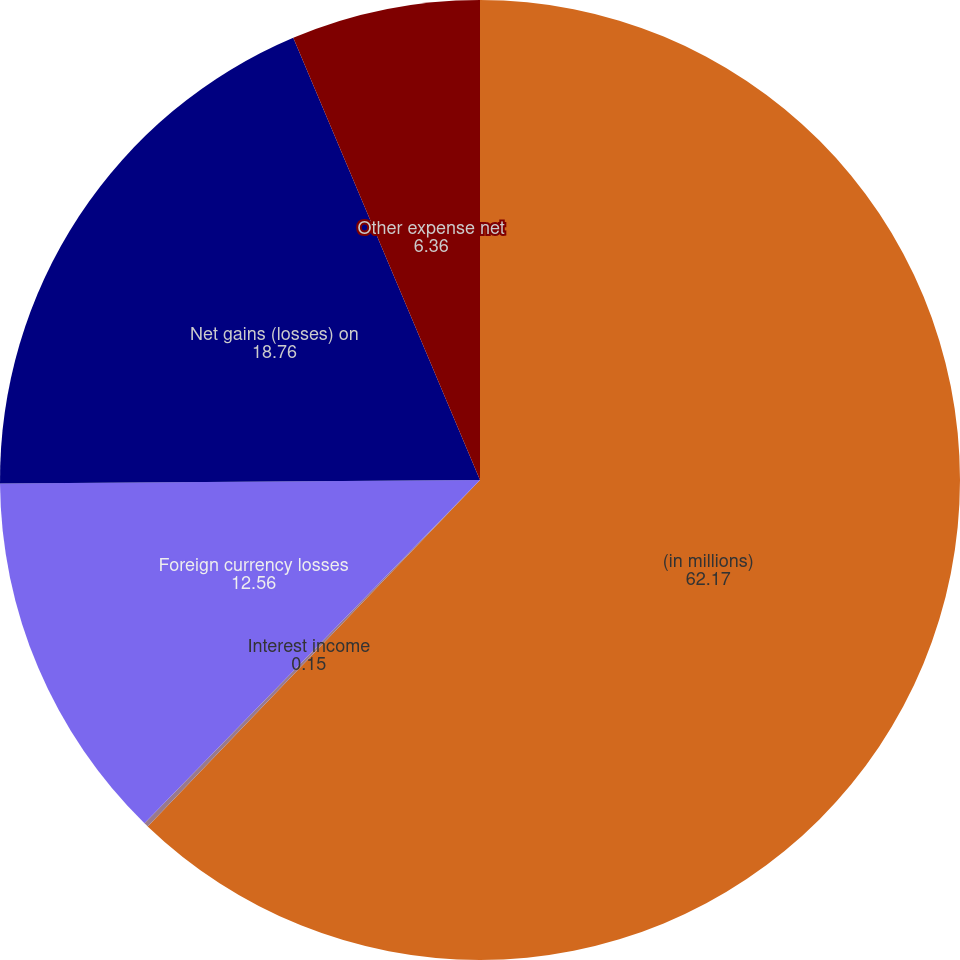Convert chart to OTSL. <chart><loc_0><loc_0><loc_500><loc_500><pie_chart><fcel>(in millions)<fcel>Interest income<fcel>Foreign currency losses<fcel>Net gains (losses) on<fcel>Other expense net<nl><fcel>62.17%<fcel>0.15%<fcel>12.56%<fcel>18.76%<fcel>6.36%<nl></chart> 